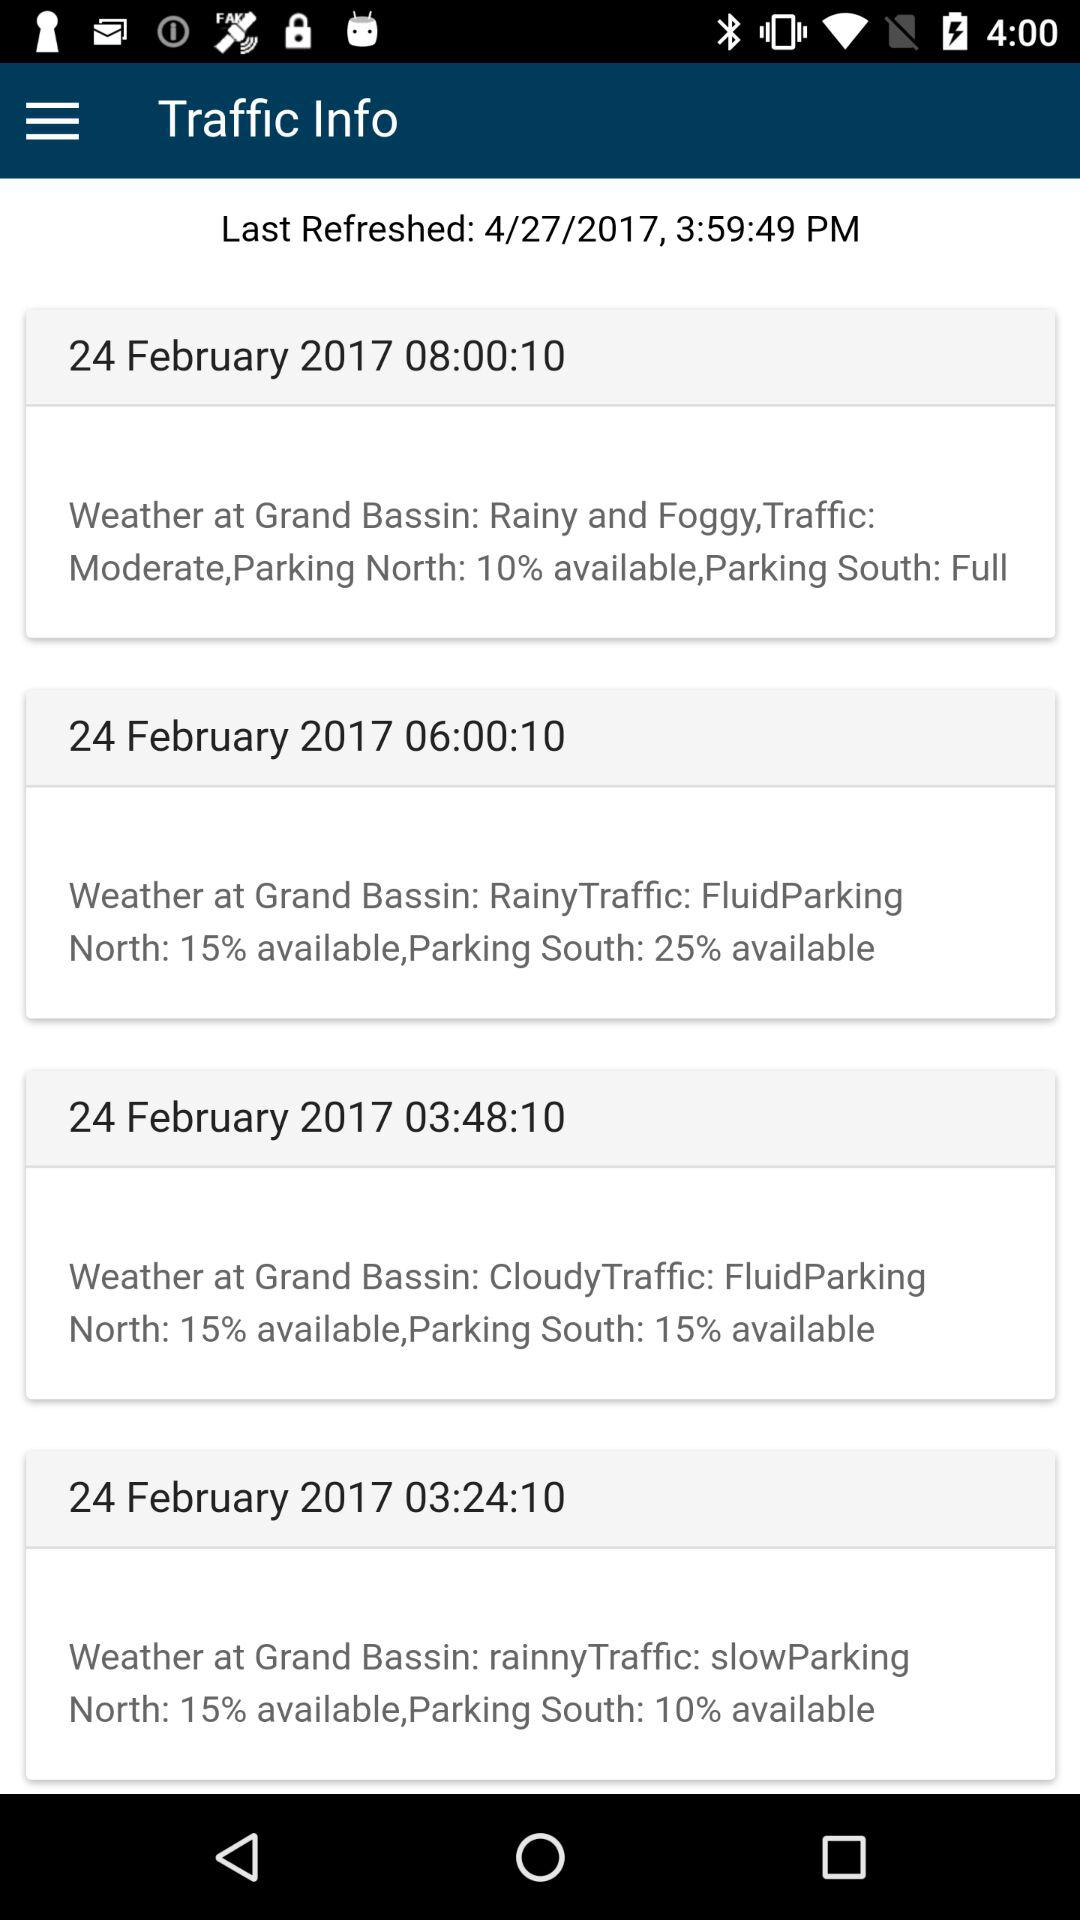Who posted the traffic information?
When the provided information is insufficient, respond with <no answer>. <no answer> 